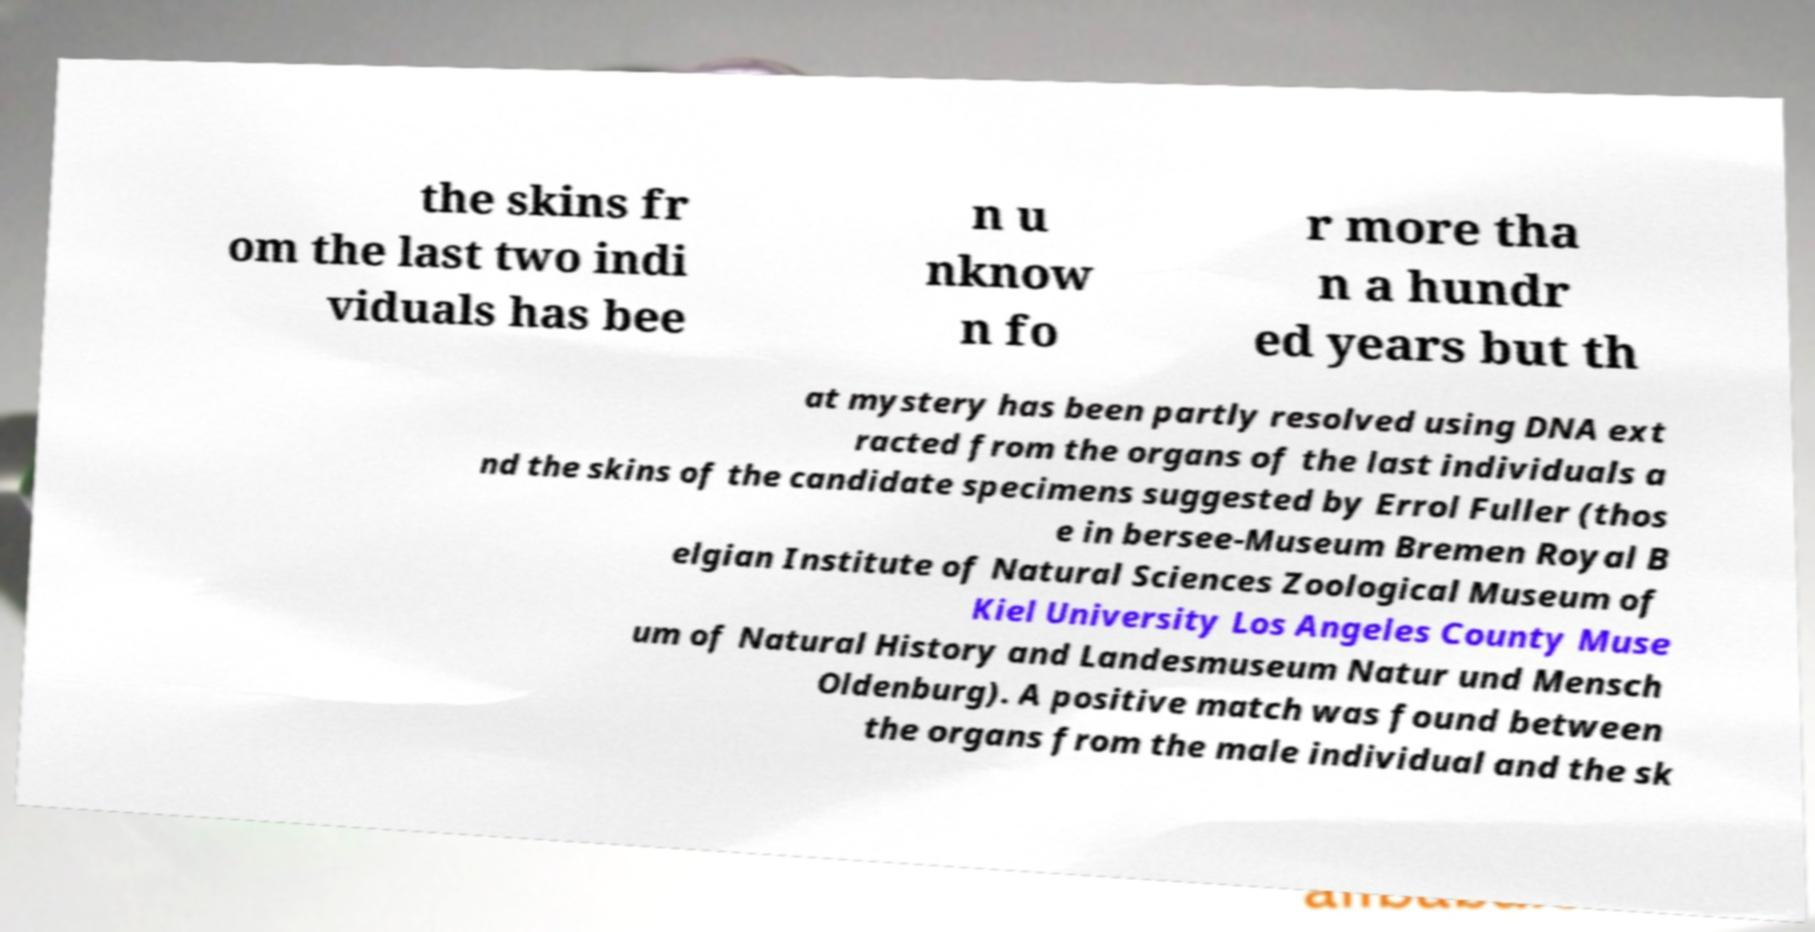There's text embedded in this image that I need extracted. Can you transcribe it verbatim? the skins fr om the last two indi viduals has bee n u nknow n fo r more tha n a hundr ed years but th at mystery has been partly resolved using DNA ext racted from the organs of the last individuals a nd the skins of the candidate specimens suggested by Errol Fuller (thos e in bersee-Museum Bremen Royal B elgian Institute of Natural Sciences Zoological Museum of Kiel University Los Angeles County Muse um of Natural History and Landesmuseum Natur und Mensch Oldenburg). A positive match was found between the organs from the male individual and the sk 